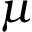Convert formula to latex. <formula><loc_0><loc_0><loc_500><loc_500>\mu</formula> 